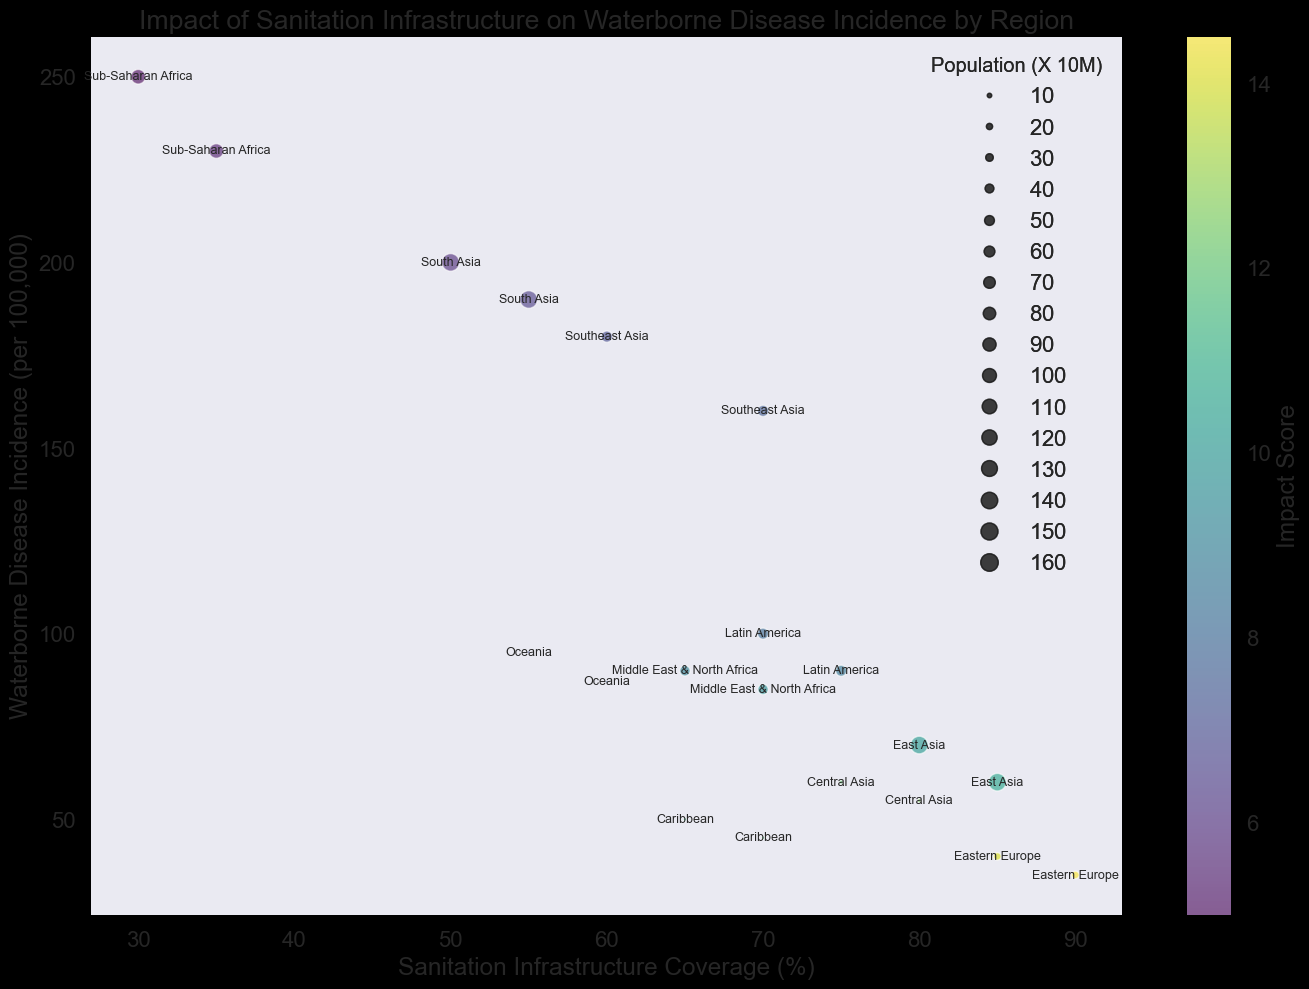Which region has the highest sanitation infrastructure coverage? By looking at the horizontal axis, Eastern Europe has the highest value at 90%, indicating the highest sanitation infrastructure coverage.
Answer: Eastern Europe Which region has the highest waterborne disease incidence? By checking the vertical axis, Sub-Saharan Africa has the highest waterborne disease incidence around 230 per 100,000 people.
Answer: Sub-Saharan Africa Which region has a higher sanitation infrastructure coverage, Caribbean or Oceania? By comparing the horizontal positions of Caribbean and Oceania, Caribbean has a coverage of 70% while Oceania has 60%. Therefore, Caribbean has higher coverage.
Answer: Caribbean Does a higher sanitation infrastructure coverage generally correlate with lower waterborne disease incidence? By observing the general trend in the plot, regions with higher sanitation coverage (towards the right) tend to have lower waterborne disease incidence (lower on the vertical axis).
Answer: Yes Which regions have an impact score of 10 or higher and where are they placed on the plot? By checking the color intensity representing the impact score, regions like East Asia, Central Asia, Eastern Europe, and Caribbean have impact scores of 10 or higher, and they are typically positioned on the right side with higher sanitation and lower disease incidence.
Answer: East Asia, Central Asia, Eastern Europe, Caribbean What is the relationship between population size and sanitation infrastructure coverage? Larger bubbles (representing larger populations) tend to have varied sanitation coverage but are more frequently found in regions with moderate to higher sanitation coverage. For example, East Asia and South Asia, which are large bubbles, have high and moderate coverage respectively.
Answer: Varied but often moderate to high coverage Compare the impact scores of Central Asia and Latin America. Which is higher? By examining the color gradient, Central Asia has a more intense shade indicating a higher impact score of 12.5 compared to Latin America which has 8.5.
Answer: Central Asia What is the approximate difference in sanitation infrastructure coverage between Sub-Saharan Africa and Eastern Europe? Sub-Saharan Africa has a coverage of around 35%, while Eastern Europe has 90%. The difference is 90% - 35% = 55%.
Answer: 55% Which region has a significant population but moderate waterborne disease incidence and medium sanitation infrastructure? South Asia stands out with a significant bubble size indicating a large population, moderate disease incidence around 190, and medium infrastructure coverage at 55%.
Answer: South Asia Among the regions with a sanitation infrastructure coverage of 70%, which one has the lowest impact score? By checking the regions with 70% coverage, Latin America and Caribbean have this coverage, and Latin America's impact score is 8.5 compared to Caribbean's 11.5, making Latin America's impact score the lowest.
Answer: Latin America 